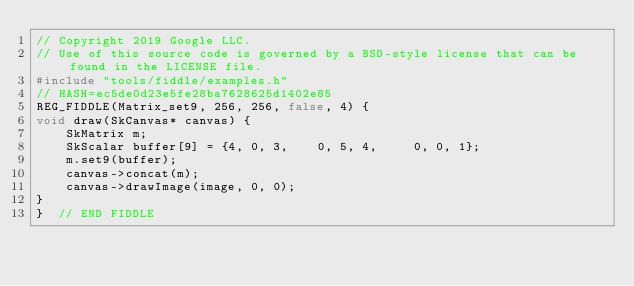Convert code to text. <code><loc_0><loc_0><loc_500><loc_500><_C++_>// Copyright 2019 Google LLC.
// Use of this source code is governed by a BSD-style license that can be found in the LICENSE file.
#include "tools/fiddle/examples.h"
// HASH=ec5de0d23e5fe28ba7628625d1402e85
REG_FIDDLE(Matrix_set9, 256, 256, false, 4) {
void draw(SkCanvas* canvas) {
    SkMatrix m;
    SkScalar buffer[9] = {4, 0, 3,    0, 5, 4,     0, 0, 1};
    m.set9(buffer);
    canvas->concat(m);
    canvas->drawImage(image, 0, 0);
}
}  // END FIDDLE
</code> 